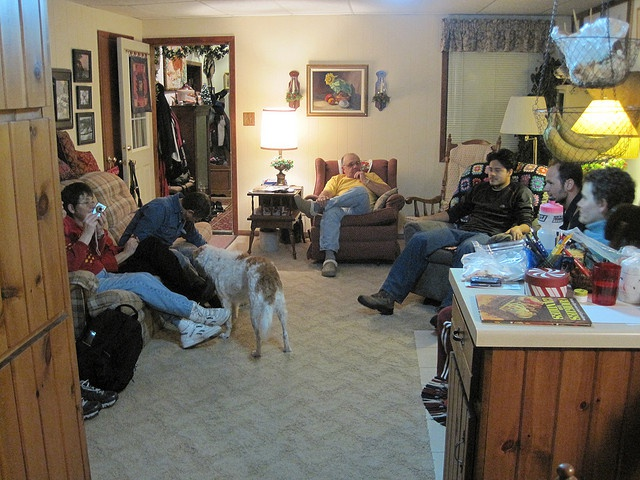Describe the objects in this image and their specific colors. I can see people in lightblue, black, gray, navy, and blue tones, people in lightblue, black, maroon, and gray tones, people in lightblue, black, navy, gray, and darkblue tones, dog in lightblue, gray, and darkgray tones, and chair in lightblue, black, and brown tones in this image. 